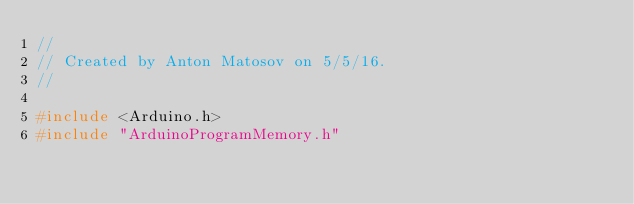Convert code to text. <code><loc_0><loc_0><loc_500><loc_500><_C++_>//
// Created by Anton Matosov on 5/5/16.
//

#include <Arduino.h>
#include "ArduinoProgramMemory.h"
</code> 